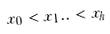Convert formula to latex. <formula><loc_0><loc_0><loc_500><loc_500>x _ { 0 } < x _ { 1 } . . < x _ { h }</formula> 